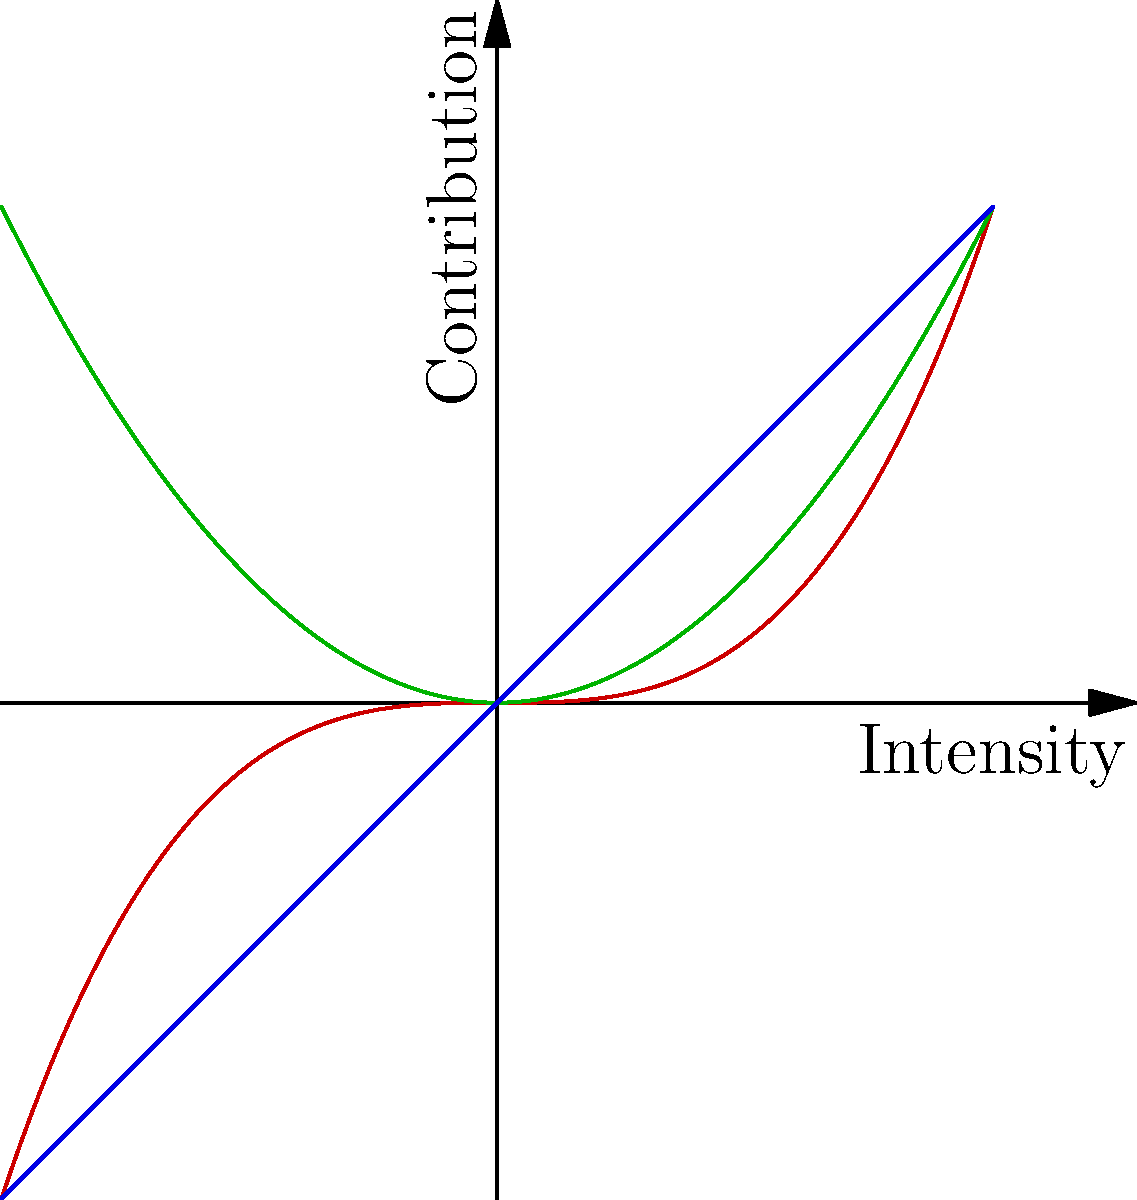In Unreal Engine 4's material editor, which color property would you adjust to increase the overall brightness of an object without affecting its reflective properties? To answer this question, let's break down the color properties in Unreal Engine 4's material editor:

1. Diffuse: This is the base color of the material. It represents how the material reflects light in a scattered way, giving the object its primary color.

2. Specular: This property controls the shininess or reflectiveness of the material. It doesn't affect the overall brightness but rather how the material reflects highlights.

3. Emissive: This property makes the material appear to emit light, increasing its brightness without affecting its reflective properties.

4. Metallic: This determines how metal-like the material appears, affecting both its color and reflectiveness.

5. Roughness: This affects how smooth or rough the material appears, influencing how light scatters on its surface.

Given that we want to increase the overall brightness without affecting reflective properties, the emissive color is the best choice. Increasing the emissive value will make the material appear to glow, effectively increasing its brightness without changing how it reflects light from other sources.

The diffuse color would change the base color, but it wouldn't necessarily make the object brighter in all lighting conditions. Specular, metallic, and roughness properties are related to reflectiveness, so they're not suitable for this purpose.
Answer: Emissive color 